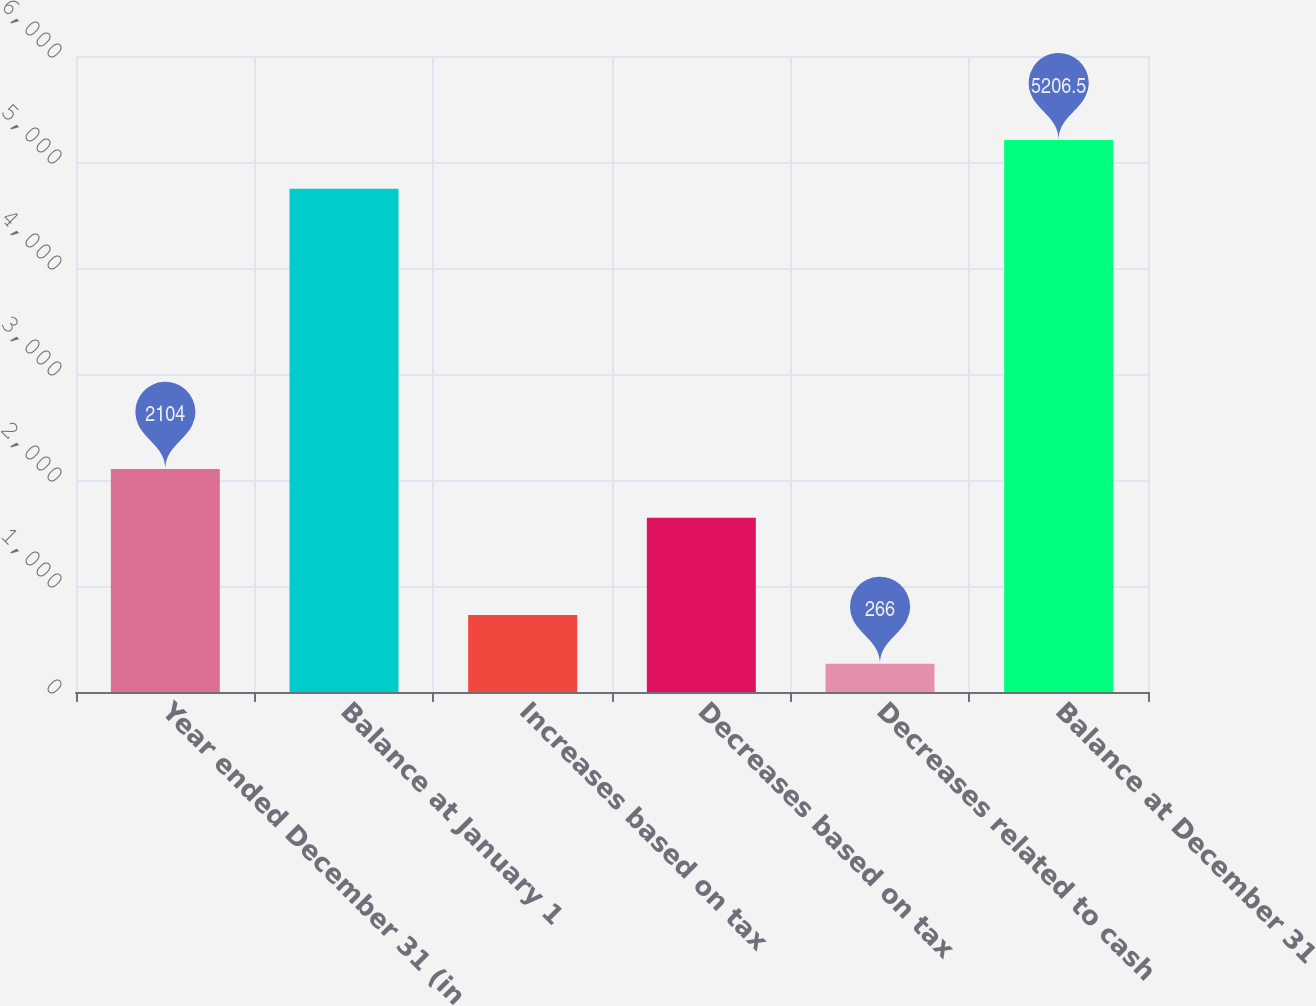Convert chart. <chart><loc_0><loc_0><loc_500><loc_500><bar_chart><fcel>Year ended December 31 (in<fcel>Balance at January 1<fcel>Increases based on tax<fcel>Decreases based on tax<fcel>Decreases related to cash<fcel>Balance at December 31<nl><fcel>2104<fcel>4747<fcel>725.5<fcel>1644.5<fcel>266<fcel>5206.5<nl></chart> 